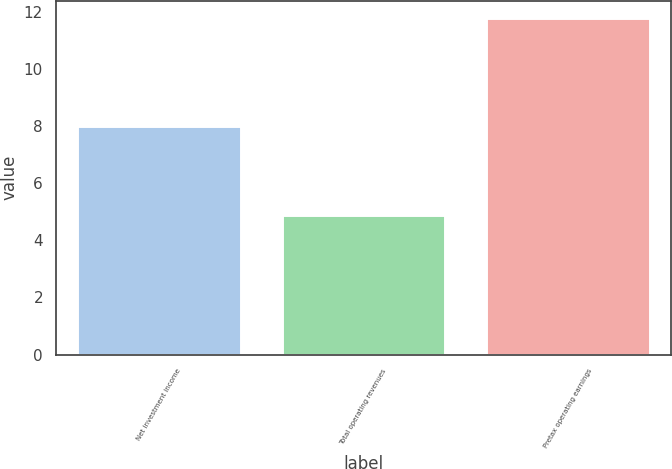Convert chart. <chart><loc_0><loc_0><loc_500><loc_500><bar_chart><fcel>Net investment income<fcel>Total operating revenues<fcel>Pretax operating earnings<nl><fcel>8<fcel>4.9<fcel>11.8<nl></chart> 